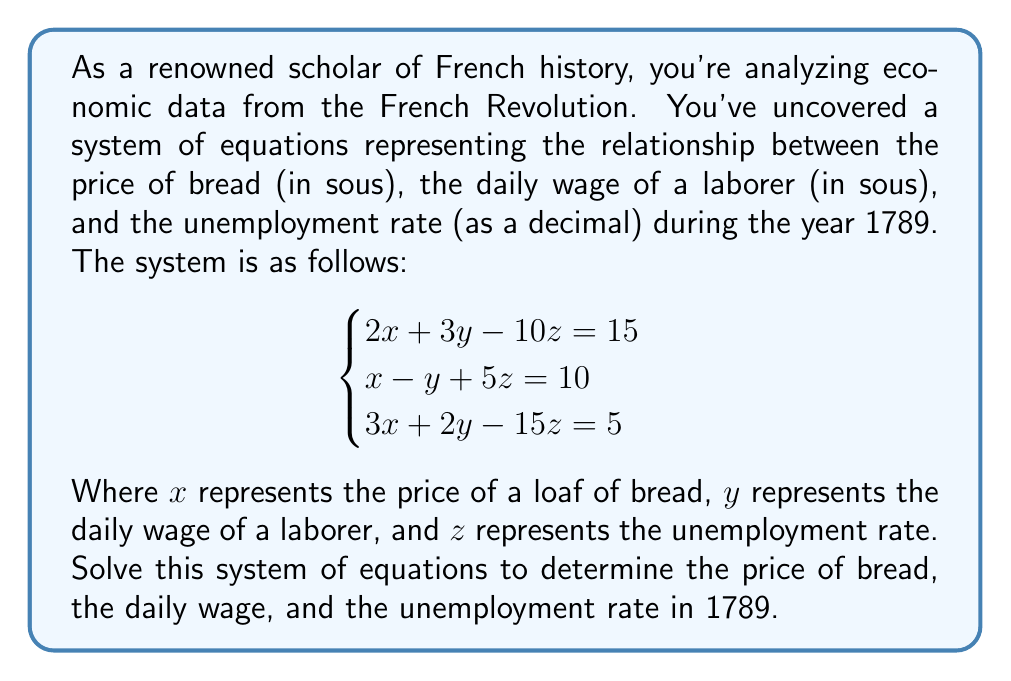Solve this math problem. To solve this system of equations, we'll use the elimination method:

1) First, let's eliminate $x$ by multiplying the second equation by 2 and subtracting it from the first equation:

   $2x + 3y - 10z = 15$
   $2x - 2y + 10z = 20$
   -------------------------
   $5y - 20z = -5$ ... (Equation 4)

2) Now, let's eliminate $x$ between the first and third equations by multiplying the first equation by 3 and subtracting it from the third equation:

   $6x + 9y - 30z = 45$
   $3x + 2y - 15z = 5$
   -------------------------
   $7y - 15z = 40$ ... (Equation 5)

3) We now have two equations without $x$. Let's eliminate $y$ between these two new equations by multiplying Equation 4 by 7 and Equation 5 by 5:

   $35y - 140z = -35$
   $35y - 75z = 200$
   -------------------------
   $-65z = 235$

4) Solving for $z$:
   $z = -\frac{235}{65} = -\frac{47}{13} \approx 3.62$

5) Substituting this value of $z$ into Equation 4:
   $5y - 20(-\frac{47}{13}) = -5$
   $5y + \frac{940}{13} = -5$
   $5y = -\frac{1005}{13}$
   $y = -\frac{201}{13} \approx 15.46$

6) Finally, substituting the values of $y$ and $z$ into the first equation:
   $2x + 3(-\frac{201}{13}) - 10(-\frac{47}{13}) = 15$
   $2x - \frac{603}{13} + \frac{470}{13} = 15$
   $2x - \frac{133}{13} = 15$
   $2x = \frac{328}{13}$
   $x = \frac{164}{13} \approx 12.62$

Therefore, the solution is:
$x = \frac{164}{13}$, $y = -\frac{201}{13}$, $z = -\frac{47}{13}$
Answer: The price of a loaf of bread in 1789 was approximately 12.62 sous, the daily wage of a laborer was approximately 15.46 sous, and the unemployment rate was approximately 3.62 or 362%. Note: The negative values for wage and unemployment rate are mathematically correct solutions to the system but are not economically meaningful, suggesting the need for historical context or reevaluation of the initial equations. 